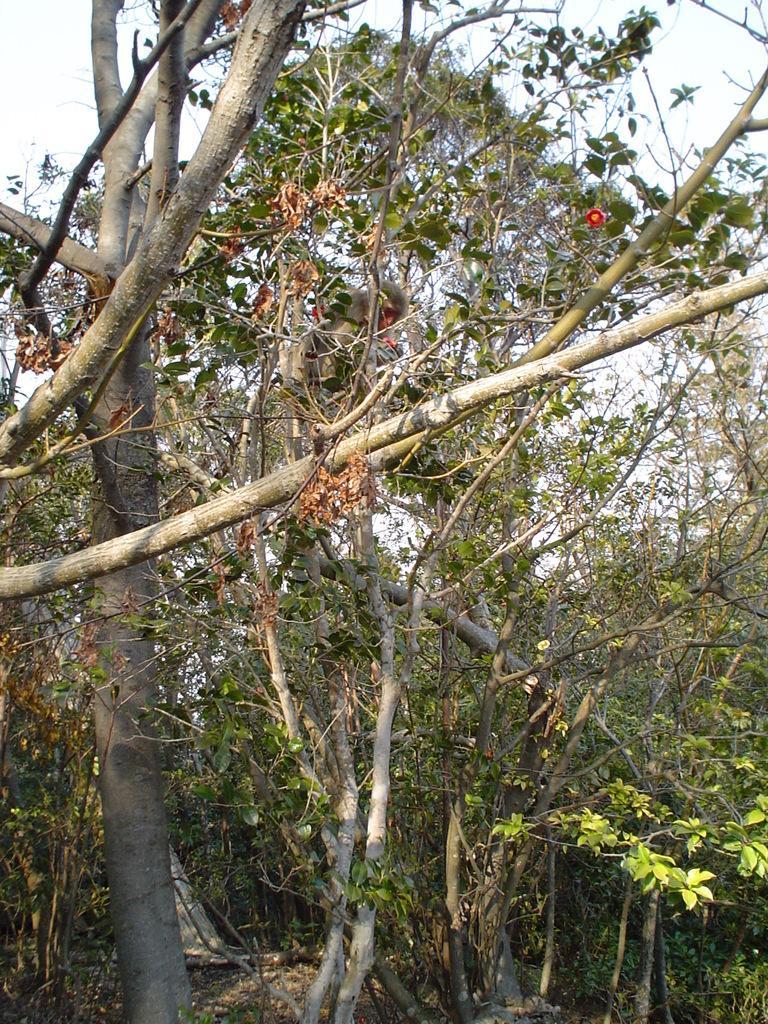Please provide a concise description of this image. In the image there are many trees with branches and stems. And in the background there is a sky. 